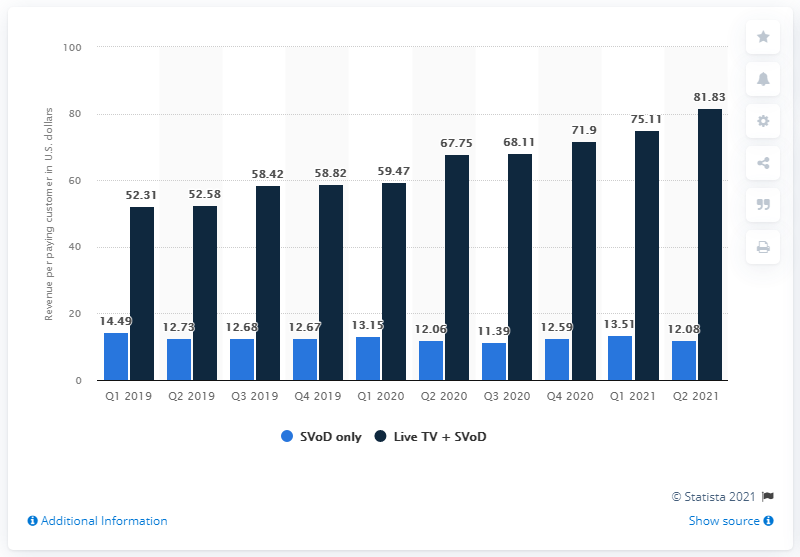Specify some key components in this picture. Second to the least revenue of SVoD (subscription video on demand) services is 12.06... The average of the highest revenue in Q2 2021 and Q4 2019 is 70.325. 